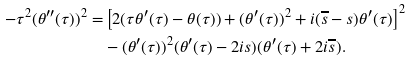<formula> <loc_0><loc_0><loc_500><loc_500>- \tau ^ { 2 } ( \theta ^ { \prime \prime } ( \tau ) ) ^ { 2 } = & \left [ 2 ( \tau \theta ^ { \prime } ( \tau ) - \theta ( \tau ) ) + ( \theta ^ { \prime } ( \tau ) ) ^ { 2 } + i ( \overline { s } - s ) \theta ^ { \prime } ( \tau ) \right ] ^ { 2 } \\ & - ( \theta ^ { \prime } ( \tau ) ) ^ { 2 } ( \theta ^ { \prime } ( \tau ) - 2 i s ) ( \theta ^ { \prime } ( \tau ) + 2 i \overline { s } ) .</formula> 